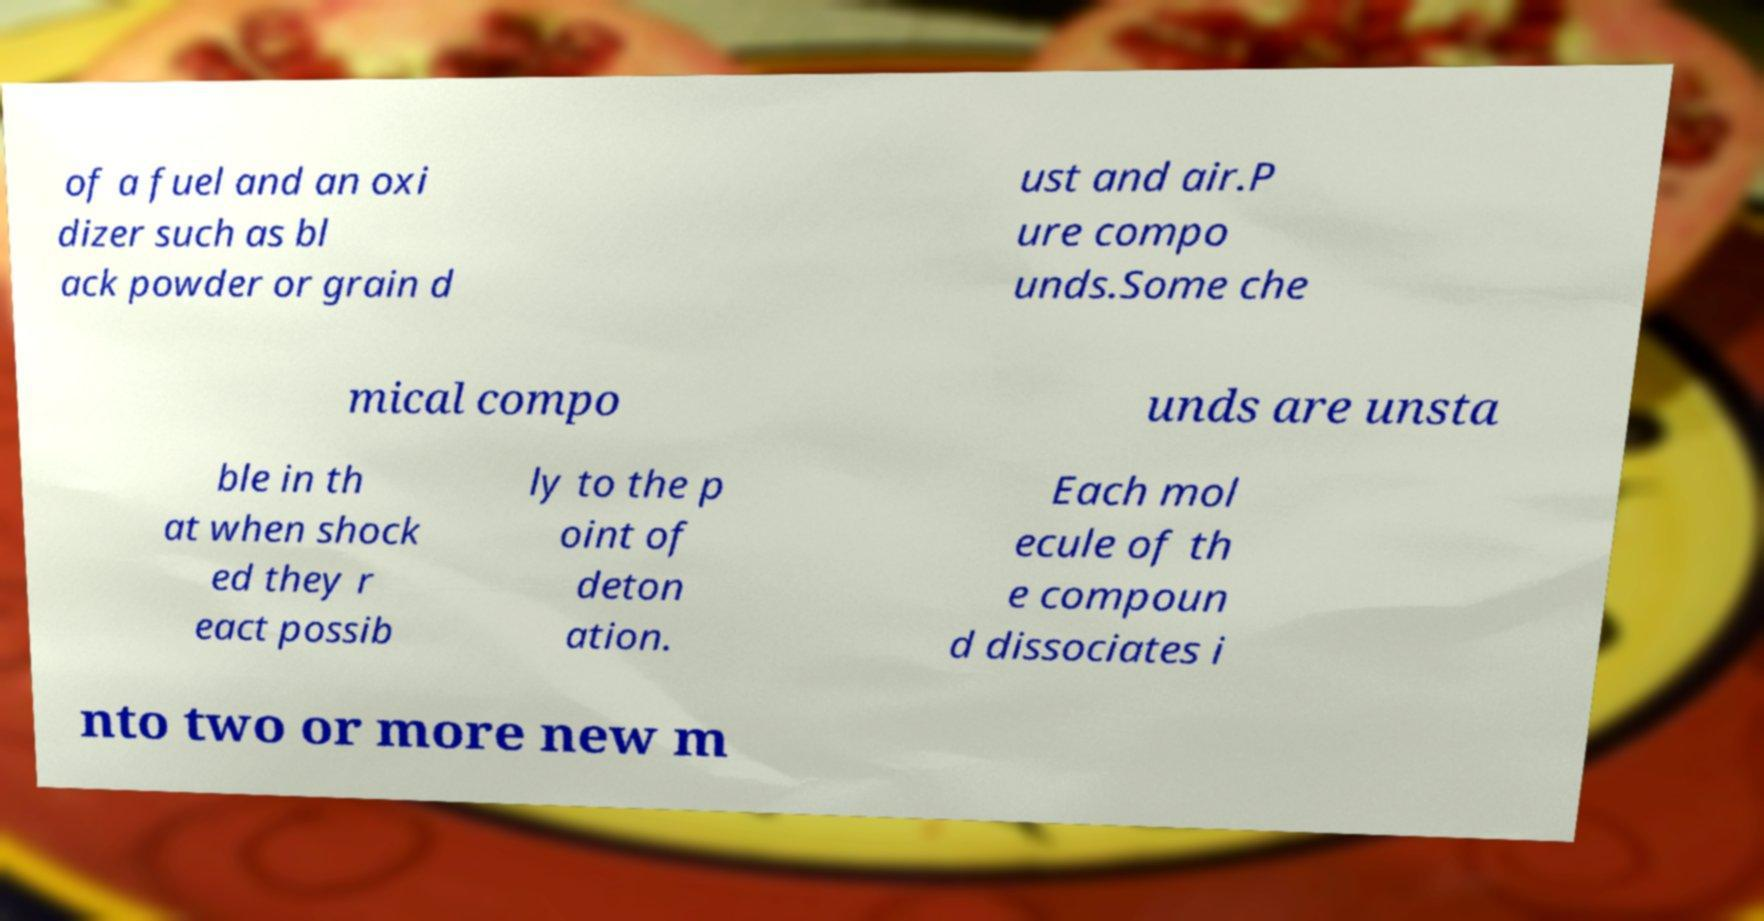For documentation purposes, I need the text within this image transcribed. Could you provide that? of a fuel and an oxi dizer such as bl ack powder or grain d ust and air.P ure compo unds.Some che mical compo unds are unsta ble in th at when shock ed they r eact possib ly to the p oint of deton ation. Each mol ecule of th e compoun d dissociates i nto two or more new m 